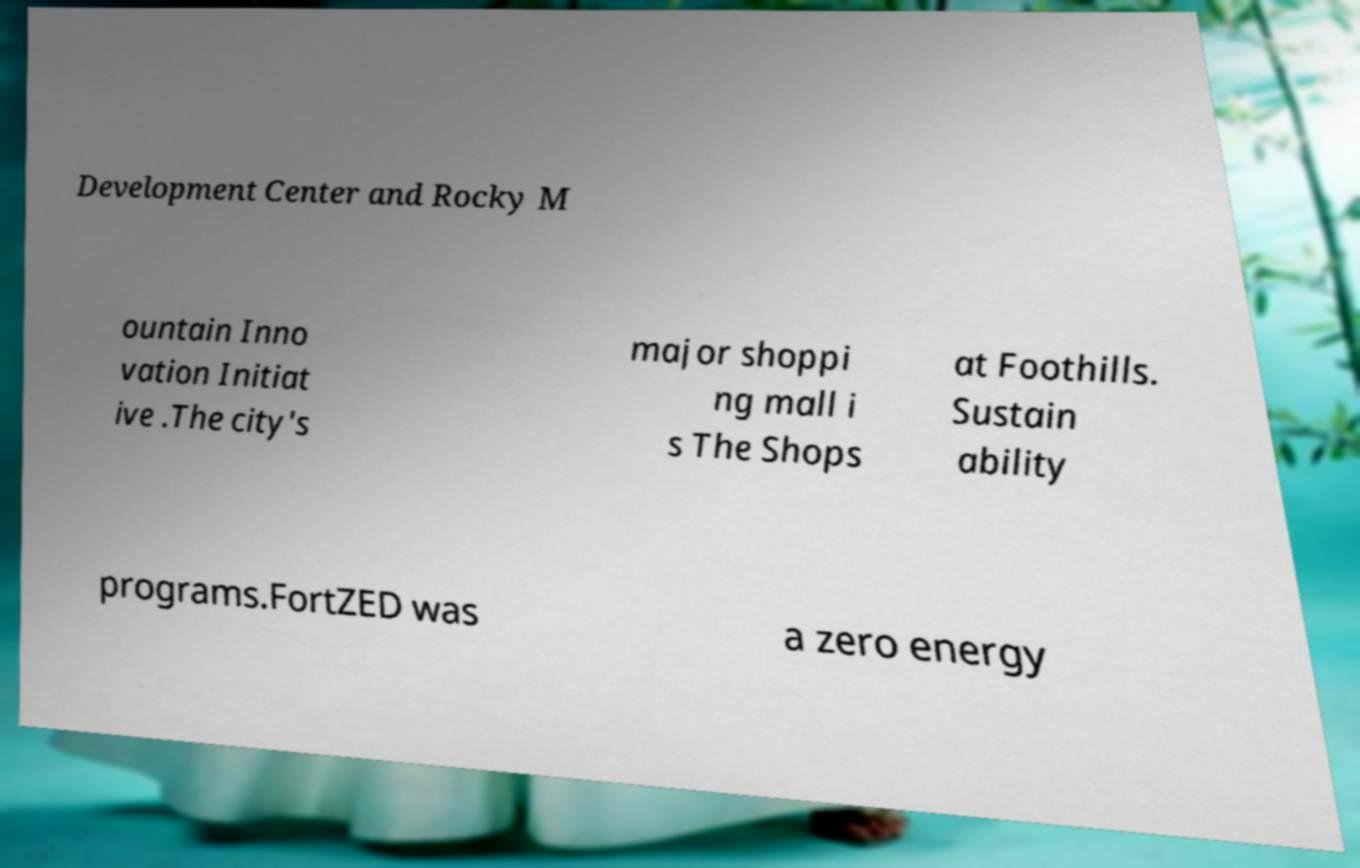I need the written content from this picture converted into text. Can you do that? Development Center and Rocky M ountain Inno vation Initiat ive .The city's major shoppi ng mall i s The Shops at Foothills. Sustain ability programs.FortZED was a zero energy 